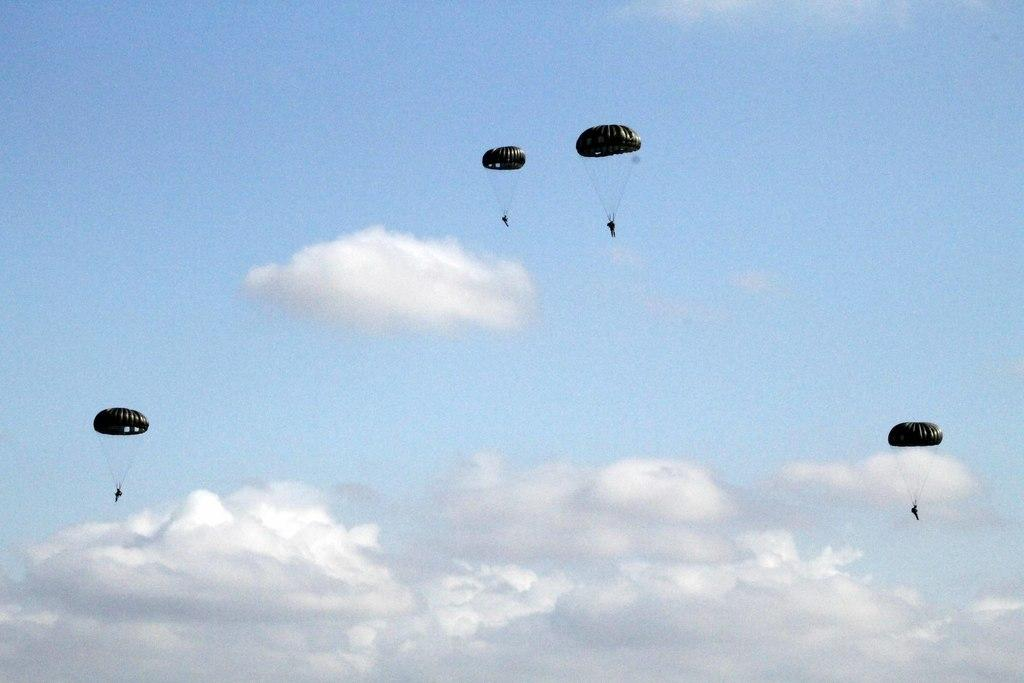Who or what is present in the image? There are people in the image. What are the people doing in the image? The people are in the air and using parachutes. What can be seen in the background of the image? There is a cloudy sky in the background of the image. What type of book can be seen in the hands of the people in the image? There are no books present in the image; the people are using parachutes in the air. 